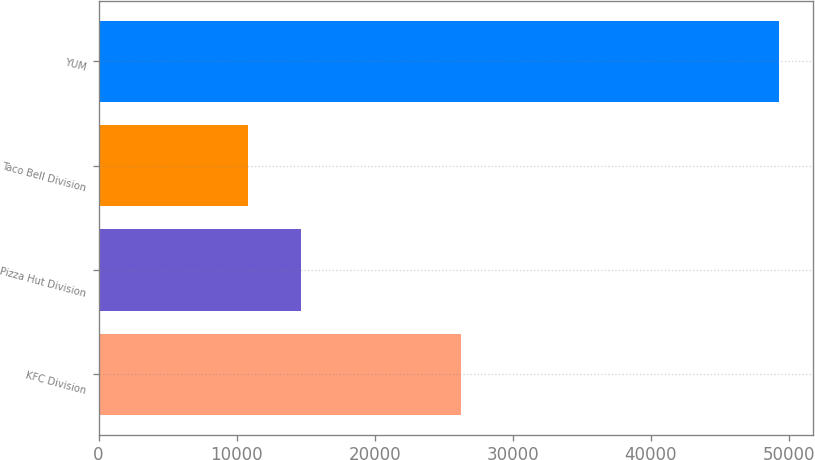Convert chart. <chart><loc_0><loc_0><loc_500><loc_500><bar_chart><fcel>KFC Division<fcel>Pizza Hut Division<fcel>Taco Bell Division<fcel>YUM<nl><fcel>26239<fcel>14631.1<fcel>10786<fcel>49237<nl></chart> 